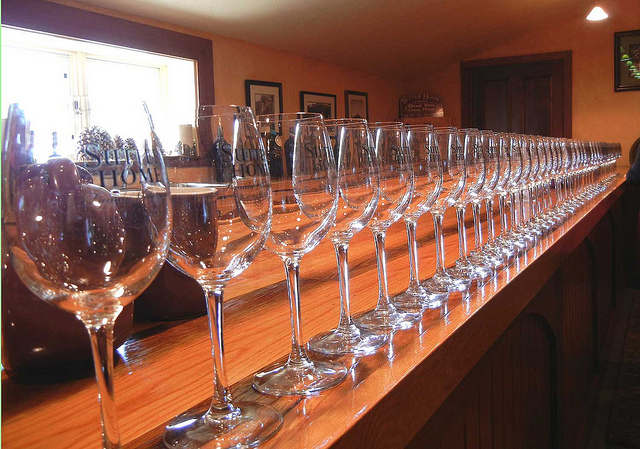<image>What beverage is in each glass? There is no beverage in the glass. It appears to be empty. What beverage is in each glass? I don't know what beverage is in each glass. It seems like there is no beverage in any of the glasses. 